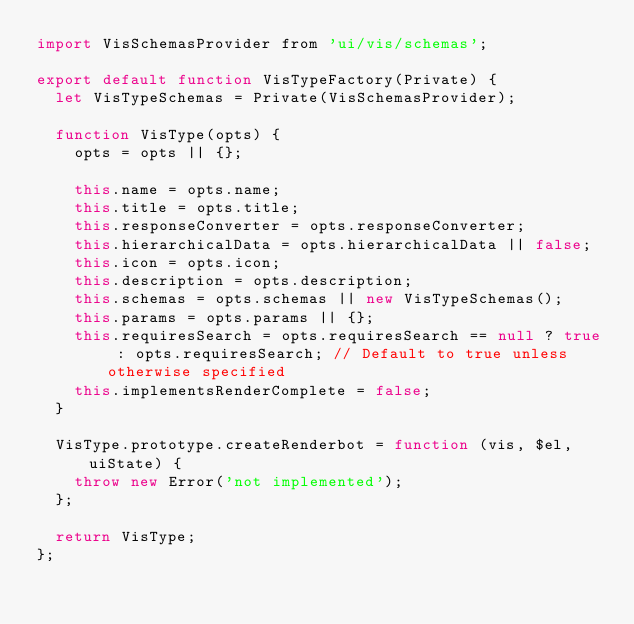<code> <loc_0><loc_0><loc_500><loc_500><_JavaScript_>import VisSchemasProvider from 'ui/vis/schemas';

export default function VisTypeFactory(Private) {
  let VisTypeSchemas = Private(VisSchemasProvider);

  function VisType(opts) {
    opts = opts || {};

    this.name = opts.name;
    this.title = opts.title;
    this.responseConverter = opts.responseConverter;
    this.hierarchicalData = opts.hierarchicalData || false;
    this.icon = opts.icon;
    this.description = opts.description;
    this.schemas = opts.schemas || new VisTypeSchemas();
    this.params = opts.params || {};
    this.requiresSearch = opts.requiresSearch == null ? true : opts.requiresSearch; // Default to true unless otherwise specified
    this.implementsRenderComplete = false;
  }

  VisType.prototype.createRenderbot = function (vis, $el, uiState) {
    throw new Error('not implemented');
  };

  return VisType;
};
</code> 